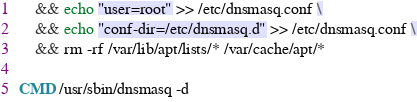<code> <loc_0><loc_0><loc_500><loc_500><_Dockerfile_>    && echo "user=root" >> /etc/dnsmasq.conf \
    && echo "conf-dir=/etc/dnsmasq.d" >> /etc/dnsmasq.conf \
    && rm -rf /var/lib/apt/lists/* /var/cache/apt/*

CMD /usr/sbin/dnsmasq -d 
</code> 